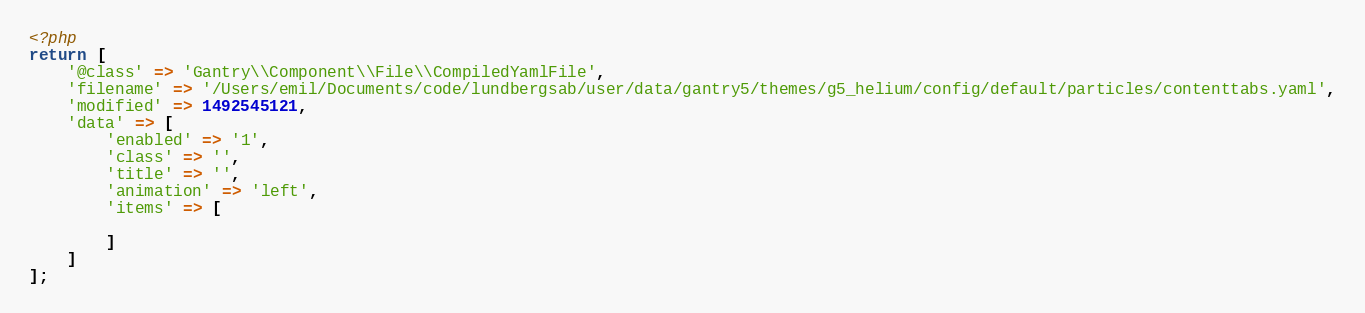Convert code to text. <code><loc_0><loc_0><loc_500><loc_500><_PHP_><?php
return [
    '@class' => 'Gantry\\Component\\File\\CompiledYamlFile',
    'filename' => '/Users/emil/Documents/code/lundbergsab/user/data/gantry5/themes/g5_helium/config/default/particles/contenttabs.yaml',
    'modified' => 1492545121,
    'data' => [
        'enabled' => '1',
        'class' => '',
        'title' => '',
        'animation' => 'left',
        'items' => [
            
        ]
    ]
];
</code> 